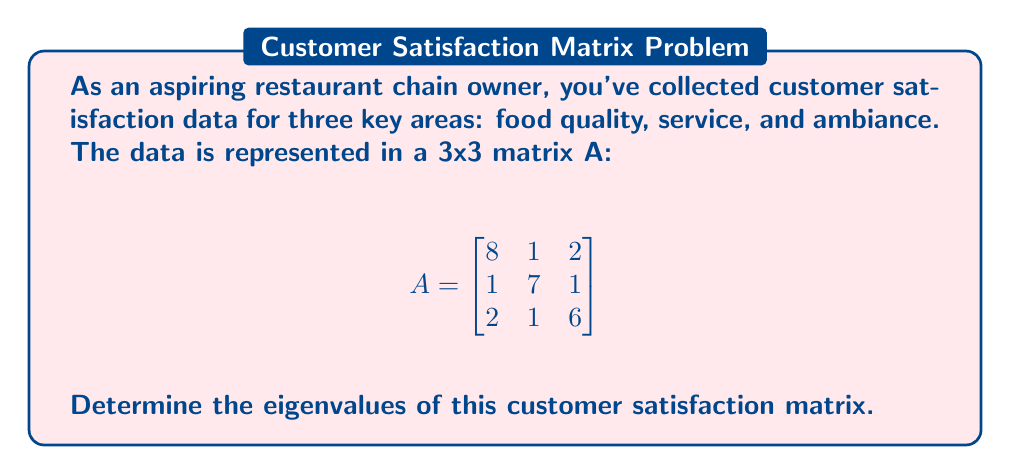Could you help me with this problem? To find the eigenvalues of matrix A, we need to solve the characteristic equation:

1) First, we set up the equation $det(A - \lambda I) = 0$, where $I$ is the 3x3 identity matrix:

   $$det\begin{pmatrix}
   8-\lambda & 1 & 2 \\
   1 & 7-\lambda & 1 \\
   2 & 1 & 6-\lambda
   \end{pmatrix} = 0$$

2) Expand the determinant:
   $(8-\lambda)[(7-\lambda)(6-\lambda) - 1] - 1[1(6-\lambda) - 2] + 2[1 - 1(7-\lambda)] = 0$

3) Simplify:
   $(8-\lambda)[(42-13\lambda+\lambda^2) - 1] - [6-\lambda - 2] + 2[-6+\lambda] = 0$
   $(8-\lambda)(41-13\lambda+\lambda^2) - 4+\lambda - 12+2\lambda = 0$

4) Expand:
   $328 - 104\lambda + 8\lambda^2 - 41\lambda + 13\lambda^2 - \lambda^3 - 4 + \lambda - 12 + 2\lambda = 0$

5) Collect terms:
   $-\lambda^3 + 21\lambda^2 - 142\lambda + 312 = 0$

6) This is the characteristic polynomial. To find its roots (the eigenvalues), we can use the cubic formula or a computer algebra system. The roots are:

   $\lambda_1 = 9$
   $\lambda_2 = 7$
   $\lambda_3 = 5$

These are the eigenvalues of the customer satisfaction matrix.
Answer: $\lambda_1 = 9$, $\lambda_2 = 7$, $\lambda_3 = 5$ 